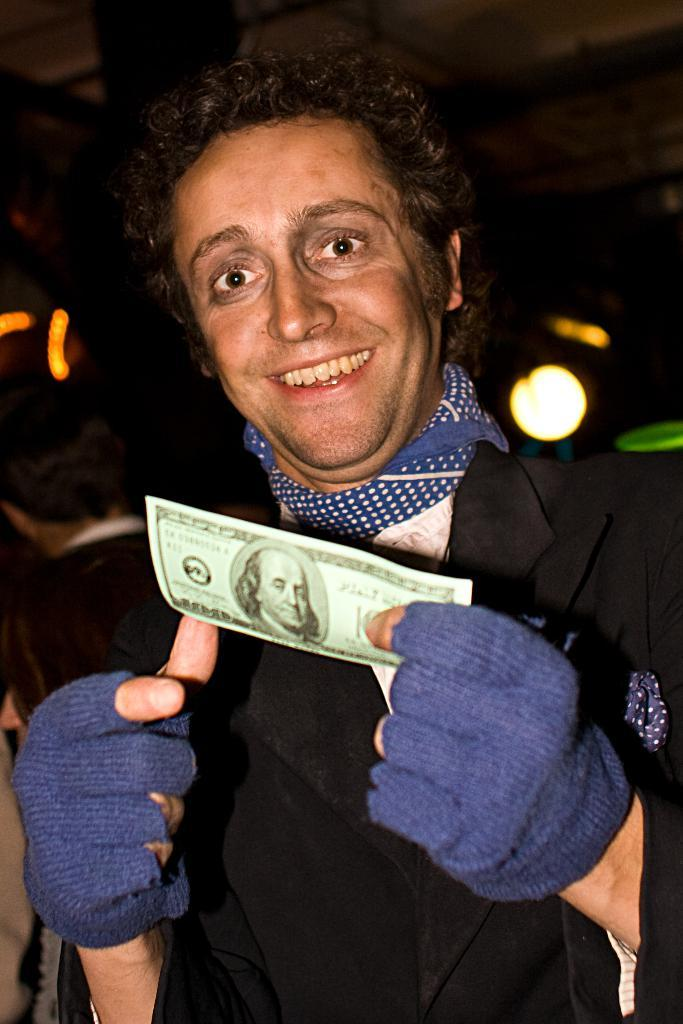What is the main subject of the image? There is a person standing in the front of the image. What is the person doing in the image? The person is smiling and holding a paper in his hand. Can you describe the background of the image? The background of the image is blurry, and there is light visible in it. What type of invention is the person demonstrating in the image? There is no invention present in the image; the person is simply holding a paper. What caption would best describe the person's action in the image? The image does not have a caption, and it is not necessary to describe the person's action with a caption. 